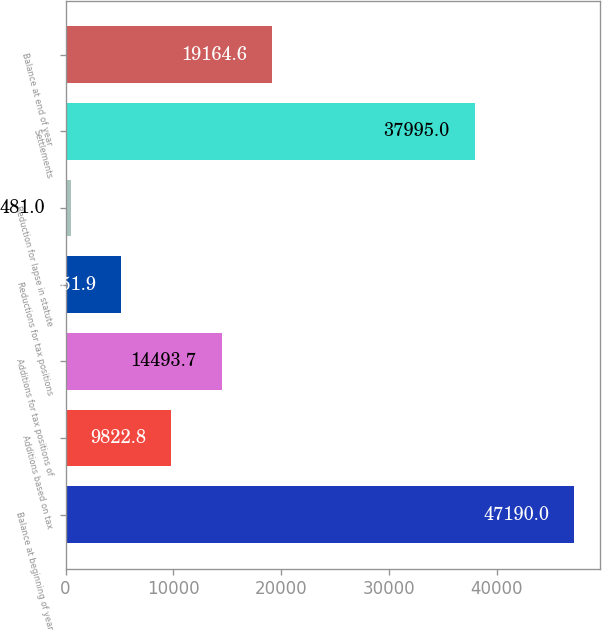Convert chart to OTSL. <chart><loc_0><loc_0><loc_500><loc_500><bar_chart><fcel>Balance at beginning of year<fcel>Additions based on tax<fcel>Additions for tax positions of<fcel>Reductions for tax positions<fcel>Reduction for lapse in statute<fcel>Settlements<fcel>Balance at end of year<nl><fcel>47190<fcel>9822.8<fcel>14493.7<fcel>5151.9<fcel>481<fcel>37995<fcel>19164.6<nl></chart> 